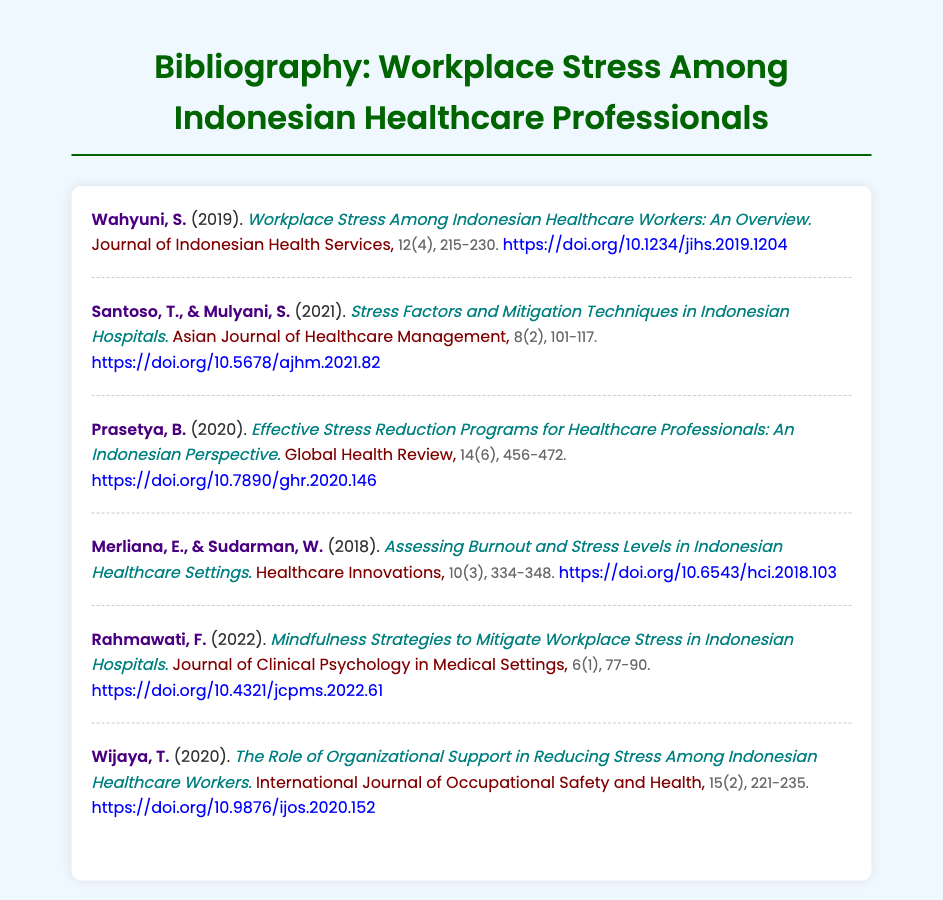What is the title of the first entry? The title of the first entry is included in the document, which states "Workplace Stress Among Indonesian Healthcare Workers: An Overview."
Answer: Workplace Stress Among Indonesian Healthcare Workers: An Overview Who is the author of the article on mindfulness strategies? The author's name is mentioned next to the title in the document for the mindfulness article.
Answer: Rahmawati, F What year was the study by Santoso and Mulyani published? The year of publication is stated in parentheses after the authors' names in the citation.
Answer: 2021 How many pages is the article by Prasetya? The number of pages is indicated in the details section of the citation.
Answer: 456-472 Which journal published the article titled "The Role of Organizational Support in Reducing Stress Among Indonesian Healthcare Workers"? The journal name is explicitly mentioned with the title of the article in the document.
Answer: International Journal of Occupational Safety and Health What volume number is associated with the article on burnout and stress levels? The volume number is included in the citation details of the corresponding entry.
Answer: 10 